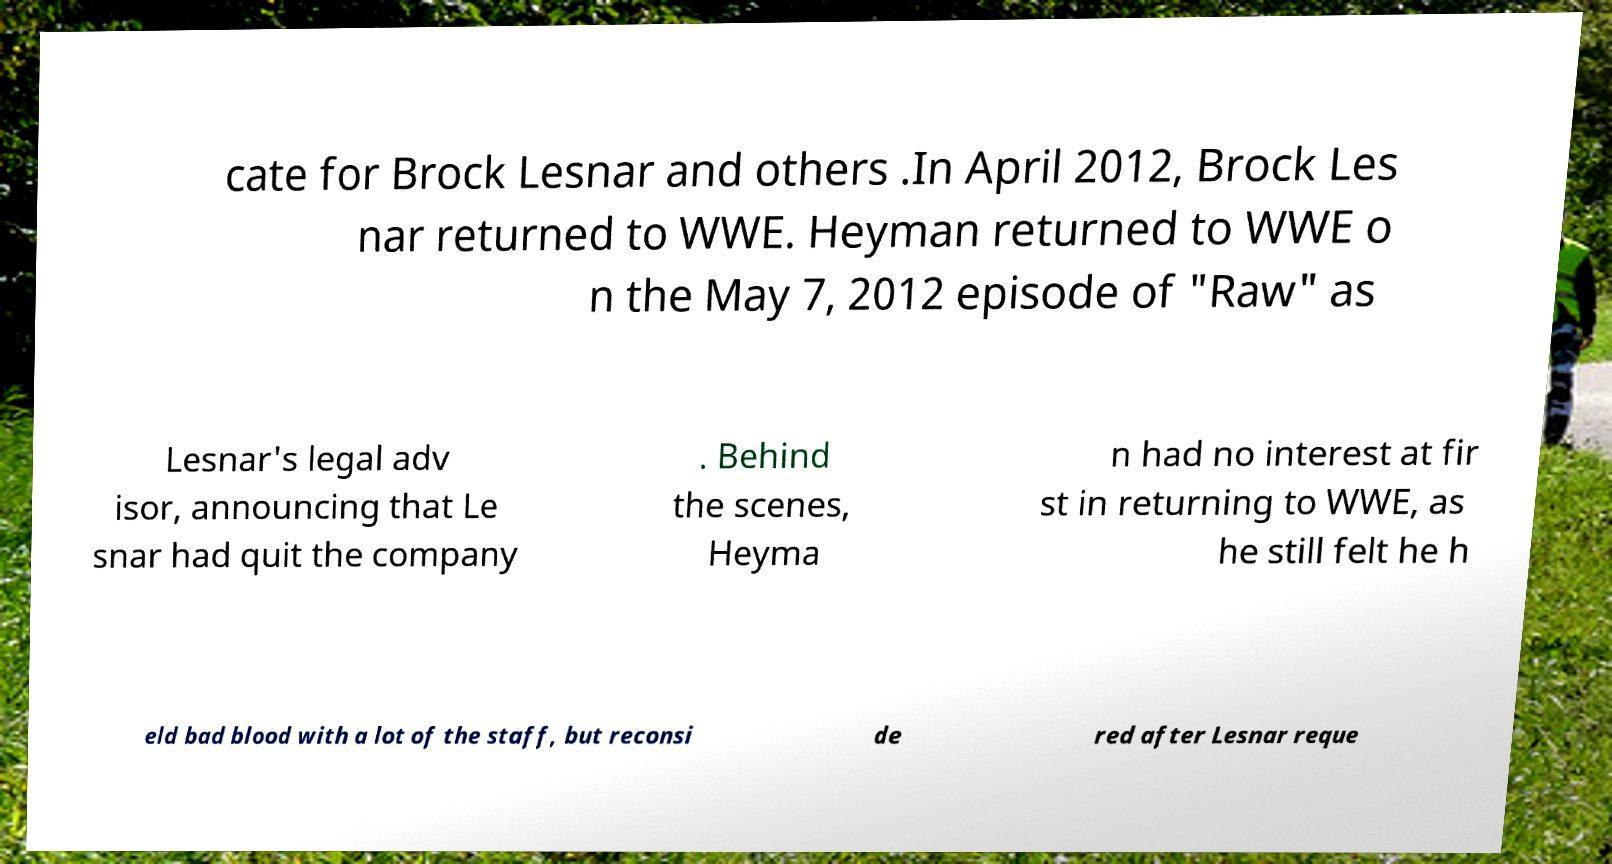Please identify and transcribe the text found in this image. cate for Brock Lesnar and others .In April 2012, Brock Les nar returned to WWE. Heyman returned to WWE o n the May 7, 2012 episode of "Raw" as Lesnar's legal adv isor, announcing that Le snar had quit the company . Behind the scenes, Heyma n had no interest at fir st in returning to WWE, as he still felt he h eld bad blood with a lot of the staff, but reconsi de red after Lesnar reque 